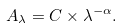<formula> <loc_0><loc_0><loc_500><loc_500>A _ { \lambda } = C \times \lambda ^ { - \alpha } .</formula> 